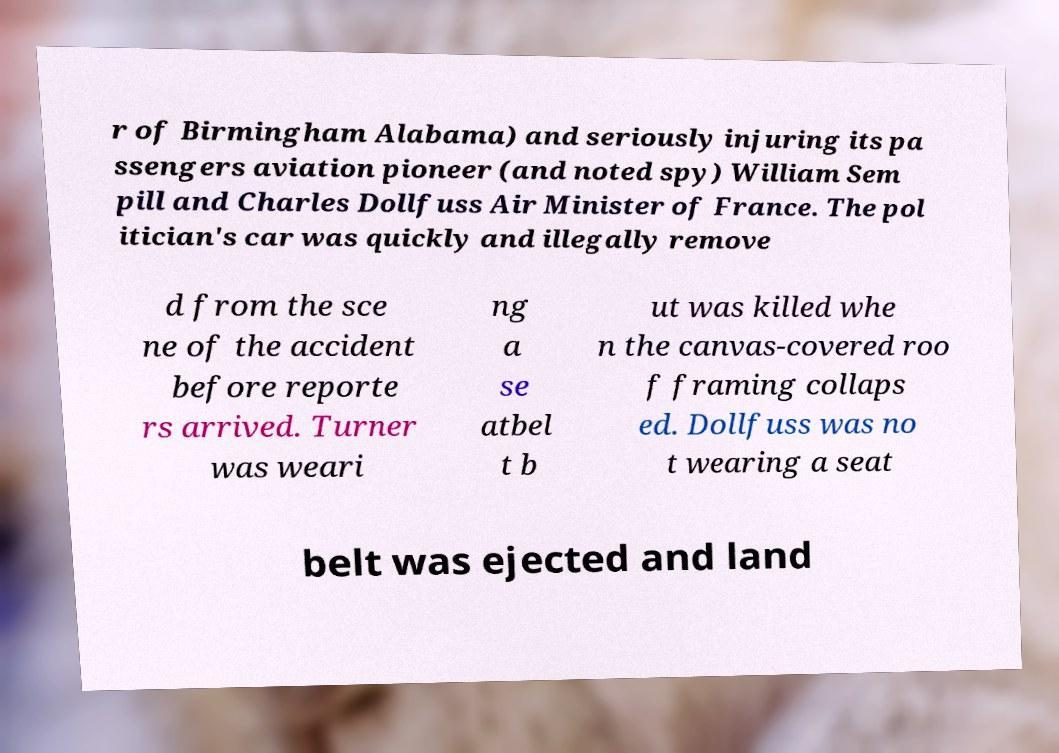Could you extract and type out the text from this image? r of Birmingham Alabama) and seriously injuring its pa ssengers aviation pioneer (and noted spy) William Sem pill and Charles Dollfuss Air Minister of France. The pol itician's car was quickly and illegally remove d from the sce ne of the accident before reporte rs arrived. Turner was weari ng a se atbel t b ut was killed whe n the canvas-covered roo f framing collaps ed. Dollfuss was no t wearing a seat belt was ejected and land 